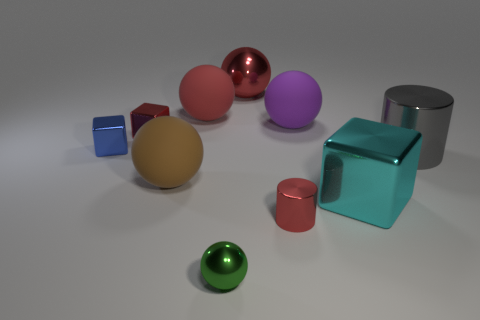If these objects had symbolic meaning, what could each represent? Interpreting the objects symbolically, the spheres might represent unity or completeness, the cubes could symbolize stability and permanence, and the cylinders might stand for continuity and motion. The colors could add another layer of meaning, with red for passion, purple for royalty, and silver and gold for wealth and prosperity. 